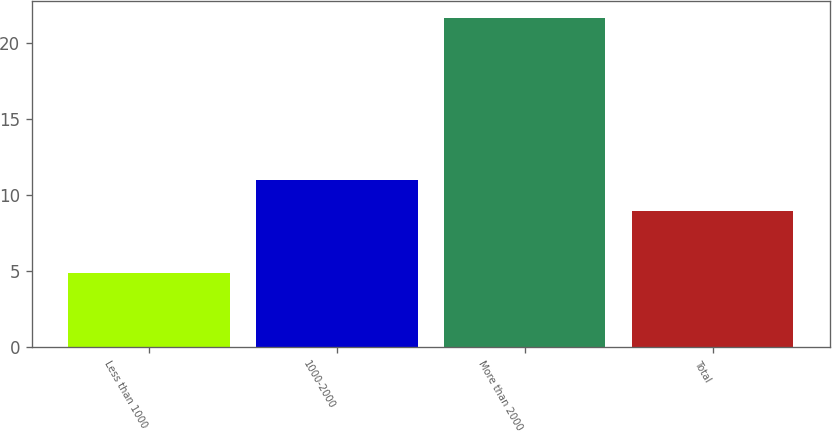<chart> <loc_0><loc_0><loc_500><loc_500><bar_chart><fcel>Less than 1000<fcel>1000-2000<fcel>More than 2000<fcel>Total<nl><fcel>4.87<fcel>10.98<fcel>21.68<fcel>8.99<nl></chart> 